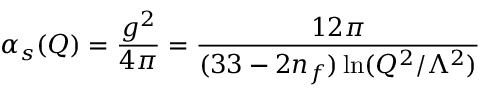Convert formula to latex. <formula><loc_0><loc_0><loc_500><loc_500>\alpha _ { s } ( Q ) = \frac { g ^ { 2 } } { 4 \pi } = \frac { 1 2 \pi } { ( 3 3 - 2 n _ { f } ) \ln ( Q ^ { 2 } / \Lambda ^ { 2 } ) }</formula> 